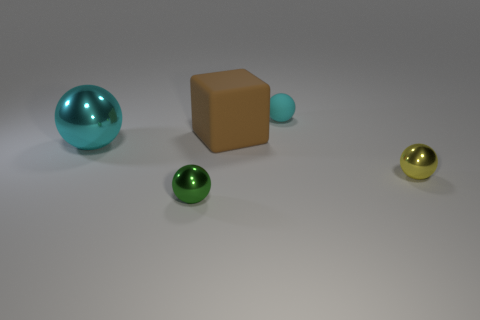How do the spheres compare to each other in terms of color and size? There are two spheres that share a similar vibrant hue of green; however, they differ significantly in size. The remaining two spheres are each of a distinct color, one teal and the other gold, and their sizes also vary, with the teal being the largest overall. 